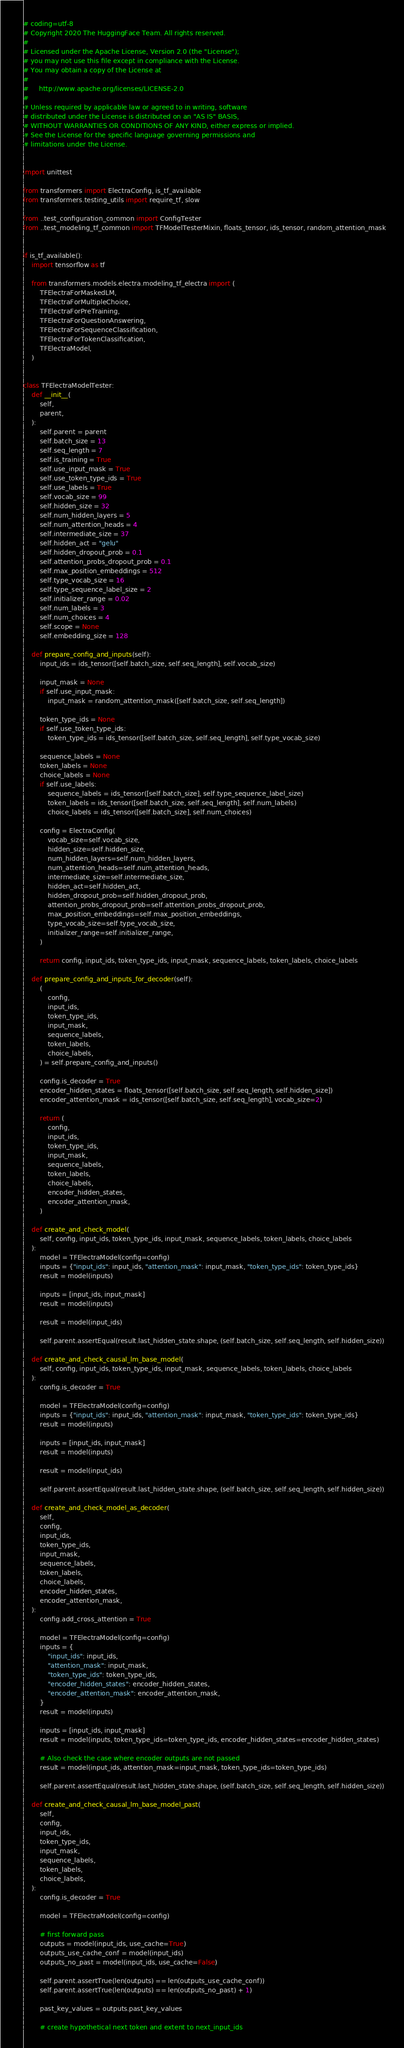Convert code to text. <code><loc_0><loc_0><loc_500><loc_500><_Python_># coding=utf-8
# Copyright 2020 The HuggingFace Team. All rights reserved.
#
# Licensed under the Apache License, Version 2.0 (the "License");
# you may not use this file except in compliance with the License.
# You may obtain a copy of the License at
#
#     http://www.apache.org/licenses/LICENSE-2.0
#
# Unless required by applicable law or agreed to in writing, software
# distributed under the License is distributed on an "AS IS" BASIS,
# WITHOUT WARRANTIES OR CONDITIONS OF ANY KIND, either express or implied.
# See the License for the specific language governing permissions and
# limitations under the License.


import unittest

from transformers import ElectraConfig, is_tf_available
from transformers.testing_utils import require_tf, slow

from ..test_configuration_common import ConfigTester
from ..test_modeling_tf_common import TFModelTesterMixin, floats_tensor, ids_tensor, random_attention_mask


if is_tf_available():
    import tensorflow as tf

    from transformers.models.electra.modeling_tf_electra import (
        TFElectraForMaskedLM,
        TFElectraForMultipleChoice,
        TFElectraForPreTraining,
        TFElectraForQuestionAnswering,
        TFElectraForSequenceClassification,
        TFElectraForTokenClassification,
        TFElectraModel,
    )


class TFElectraModelTester:
    def __init__(
        self,
        parent,
    ):
        self.parent = parent
        self.batch_size = 13
        self.seq_length = 7
        self.is_training = True
        self.use_input_mask = True
        self.use_token_type_ids = True
        self.use_labels = True
        self.vocab_size = 99
        self.hidden_size = 32
        self.num_hidden_layers = 5
        self.num_attention_heads = 4
        self.intermediate_size = 37
        self.hidden_act = "gelu"
        self.hidden_dropout_prob = 0.1
        self.attention_probs_dropout_prob = 0.1
        self.max_position_embeddings = 512
        self.type_vocab_size = 16
        self.type_sequence_label_size = 2
        self.initializer_range = 0.02
        self.num_labels = 3
        self.num_choices = 4
        self.scope = None
        self.embedding_size = 128

    def prepare_config_and_inputs(self):
        input_ids = ids_tensor([self.batch_size, self.seq_length], self.vocab_size)

        input_mask = None
        if self.use_input_mask:
            input_mask = random_attention_mask([self.batch_size, self.seq_length])

        token_type_ids = None
        if self.use_token_type_ids:
            token_type_ids = ids_tensor([self.batch_size, self.seq_length], self.type_vocab_size)

        sequence_labels = None
        token_labels = None
        choice_labels = None
        if self.use_labels:
            sequence_labels = ids_tensor([self.batch_size], self.type_sequence_label_size)
            token_labels = ids_tensor([self.batch_size, self.seq_length], self.num_labels)
            choice_labels = ids_tensor([self.batch_size], self.num_choices)

        config = ElectraConfig(
            vocab_size=self.vocab_size,
            hidden_size=self.hidden_size,
            num_hidden_layers=self.num_hidden_layers,
            num_attention_heads=self.num_attention_heads,
            intermediate_size=self.intermediate_size,
            hidden_act=self.hidden_act,
            hidden_dropout_prob=self.hidden_dropout_prob,
            attention_probs_dropout_prob=self.attention_probs_dropout_prob,
            max_position_embeddings=self.max_position_embeddings,
            type_vocab_size=self.type_vocab_size,
            initializer_range=self.initializer_range,
        )

        return config, input_ids, token_type_ids, input_mask, sequence_labels, token_labels, choice_labels

    def prepare_config_and_inputs_for_decoder(self):
        (
            config,
            input_ids,
            token_type_ids,
            input_mask,
            sequence_labels,
            token_labels,
            choice_labels,
        ) = self.prepare_config_and_inputs()

        config.is_decoder = True
        encoder_hidden_states = floats_tensor([self.batch_size, self.seq_length, self.hidden_size])
        encoder_attention_mask = ids_tensor([self.batch_size, self.seq_length], vocab_size=2)

        return (
            config,
            input_ids,
            token_type_ids,
            input_mask,
            sequence_labels,
            token_labels,
            choice_labels,
            encoder_hidden_states,
            encoder_attention_mask,
        )

    def create_and_check_model(
        self, config, input_ids, token_type_ids, input_mask, sequence_labels, token_labels, choice_labels
    ):
        model = TFElectraModel(config=config)
        inputs = {"input_ids": input_ids, "attention_mask": input_mask, "token_type_ids": token_type_ids}
        result = model(inputs)

        inputs = [input_ids, input_mask]
        result = model(inputs)

        result = model(input_ids)

        self.parent.assertEqual(result.last_hidden_state.shape, (self.batch_size, self.seq_length, self.hidden_size))

    def create_and_check_causal_lm_base_model(
        self, config, input_ids, token_type_ids, input_mask, sequence_labels, token_labels, choice_labels
    ):
        config.is_decoder = True

        model = TFElectraModel(config=config)
        inputs = {"input_ids": input_ids, "attention_mask": input_mask, "token_type_ids": token_type_ids}
        result = model(inputs)

        inputs = [input_ids, input_mask]
        result = model(inputs)

        result = model(input_ids)

        self.parent.assertEqual(result.last_hidden_state.shape, (self.batch_size, self.seq_length, self.hidden_size))

    def create_and_check_model_as_decoder(
        self,
        config,
        input_ids,
        token_type_ids,
        input_mask,
        sequence_labels,
        token_labels,
        choice_labels,
        encoder_hidden_states,
        encoder_attention_mask,
    ):
        config.add_cross_attention = True

        model = TFElectraModel(config=config)
        inputs = {
            "input_ids": input_ids,
            "attention_mask": input_mask,
            "token_type_ids": token_type_ids,
            "encoder_hidden_states": encoder_hidden_states,
            "encoder_attention_mask": encoder_attention_mask,
        }
        result = model(inputs)

        inputs = [input_ids, input_mask]
        result = model(inputs, token_type_ids=token_type_ids, encoder_hidden_states=encoder_hidden_states)

        # Also check the case where encoder outputs are not passed
        result = model(input_ids, attention_mask=input_mask, token_type_ids=token_type_ids)

        self.parent.assertEqual(result.last_hidden_state.shape, (self.batch_size, self.seq_length, self.hidden_size))

    def create_and_check_causal_lm_base_model_past(
        self,
        config,
        input_ids,
        token_type_ids,
        input_mask,
        sequence_labels,
        token_labels,
        choice_labels,
    ):
        config.is_decoder = True

        model = TFElectraModel(config=config)

        # first forward pass
        outputs = model(input_ids, use_cache=True)
        outputs_use_cache_conf = model(input_ids)
        outputs_no_past = model(input_ids, use_cache=False)

        self.parent.assertTrue(len(outputs) == len(outputs_use_cache_conf))
        self.parent.assertTrue(len(outputs) == len(outputs_no_past) + 1)

        past_key_values = outputs.past_key_values

        # create hypothetical next token and extent to next_input_ids</code> 